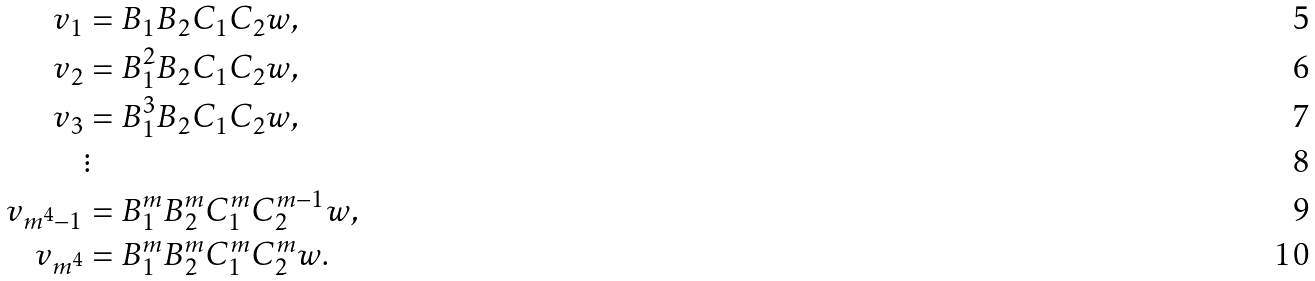<formula> <loc_0><loc_0><loc_500><loc_500>v _ { 1 } & = B _ { 1 } B _ { 2 } C _ { 1 } C _ { 2 } w , \\ v _ { 2 } & = B _ { 1 } ^ { 2 } B _ { 2 } C _ { 1 } C _ { 2 } w , \\ v _ { 3 } & = B _ { 1 } ^ { 3 } B _ { 2 } C _ { 1 } C _ { 2 } w , \\ & \vdots \\ v _ { m ^ { 4 } - 1 } & = B _ { 1 } ^ { m } B _ { 2 } ^ { m } C _ { 1 } ^ { m } C _ { 2 } ^ { m - 1 } w , \\ v _ { m ^ { 4 } } & = B _ { 1 } ^ { m } B _ { 2 } ^ { m } C _ { 1 } ^ { m } C _ { 2 } ^ { m } w .</formula> 